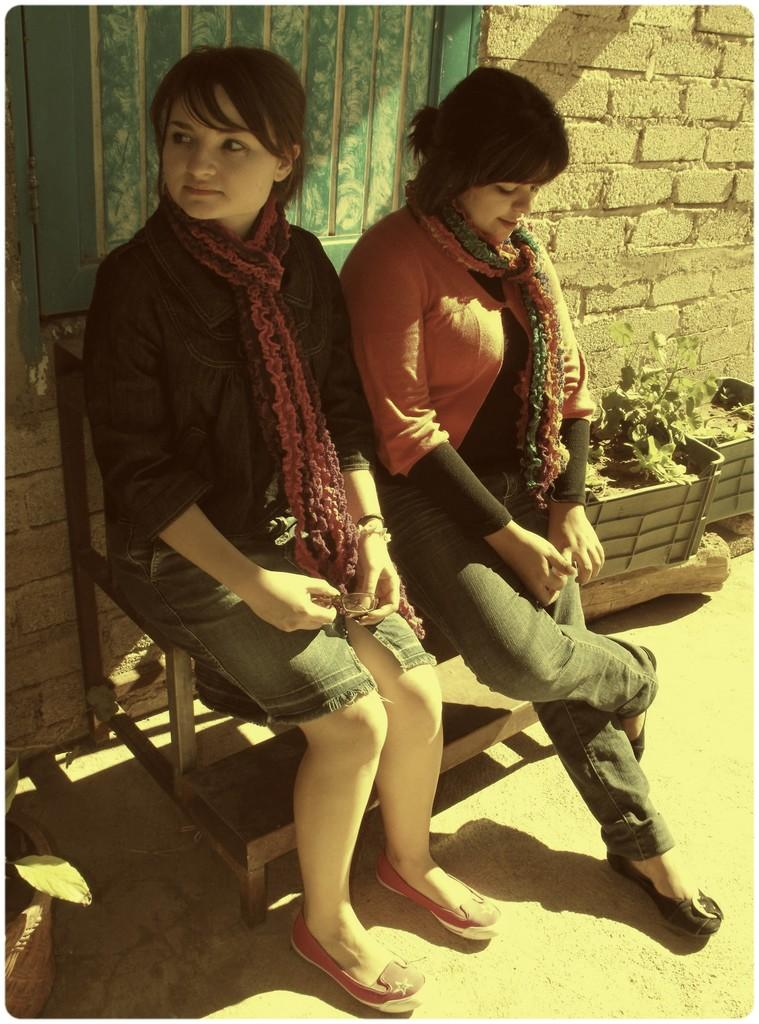How many women are in the image? There are two women in the image. What are the women wearing? The women are wearing clothes. Where are the women sitting? The women are sitting on a bench. What can be seen near the bench? There is a plant pot and a brick wall in the image. What type of vegetation is visible in the image? There are leaves visible in the image. What type of path is present in the image? There is a footpath in the image. What type of sticks are the women using to play basketball in the image? There is no basketball or sticks present in the image; the women are sitting on a bench. How does the tramp interact with the women in the image? There is no tramp present in the image; the women are sitting on a bench and there are no other people or animals visible. 